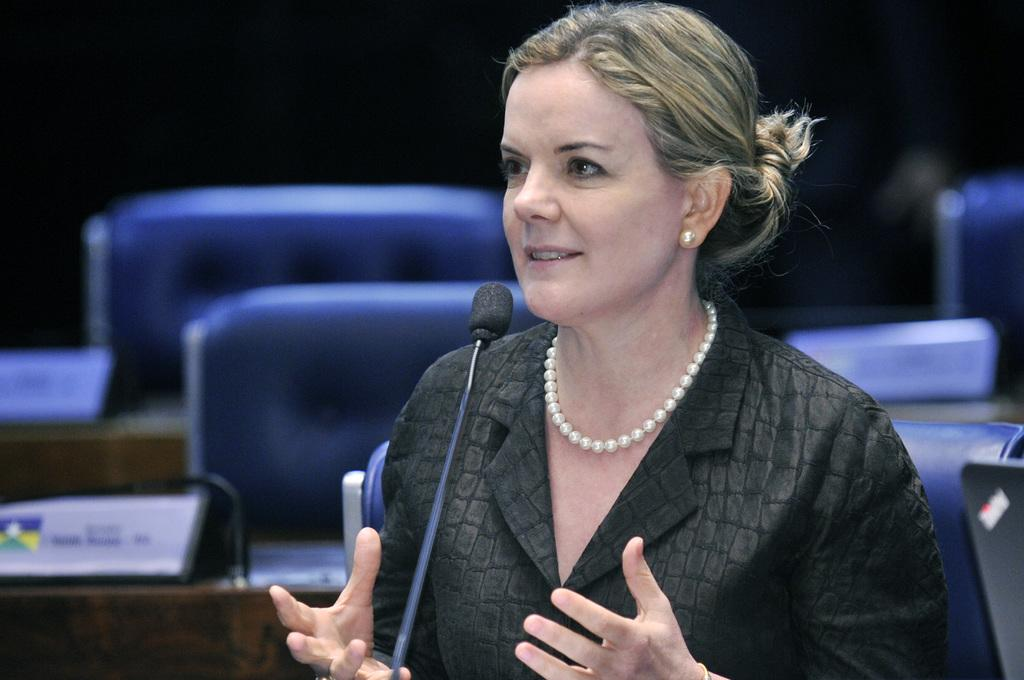Who is the main subject in the image? There is a lady in the image. What object is visible in the center of the image? There is a microphone in the image. What can be seen in the background of the image? There are chairs and name plates in the background. What type of eggnog is being served at the event in the image? There is no mention of eggnog or any event in the image. The image only shows a lady with a microphone and chairs and name plates in the background. 